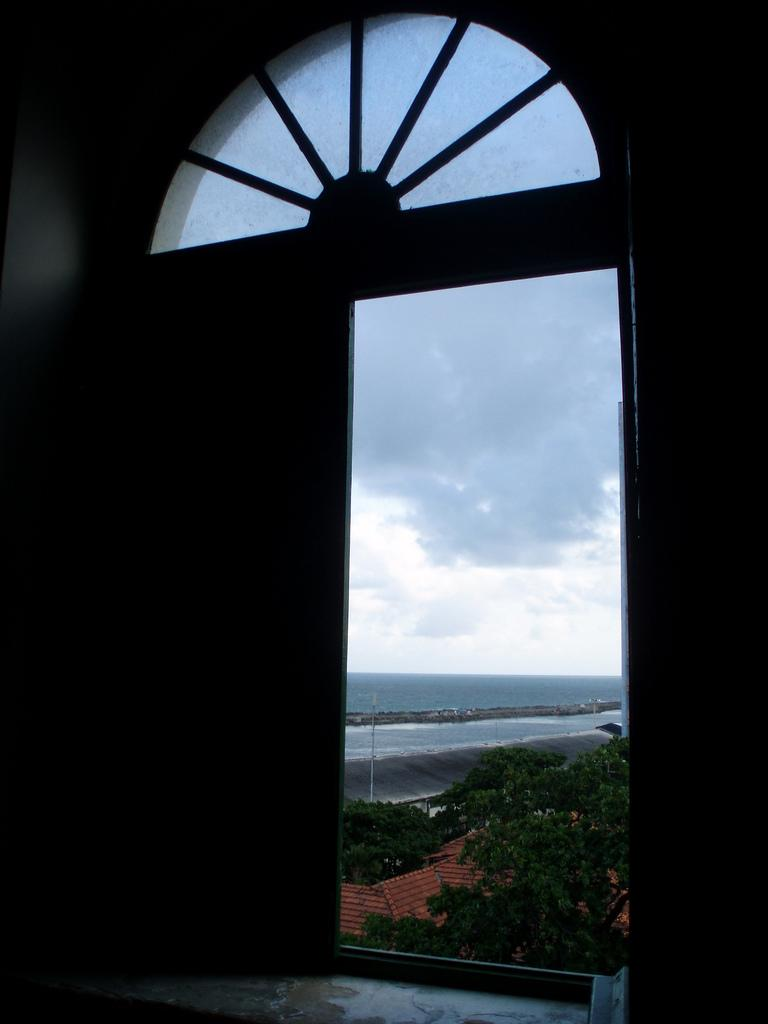What can be seen in the image that provides a view of the outdoors? There is a window in the image. What is visible in the background of the image through the window? There are trees in the background of the image. What else can be seen in the sky in the background of the image? There are clouds in the sky in the background of the image. What type of bait is being used to catch fish in the image? There is no mention of fish or bait in the image; it only features a window, trees, and clouds in the sky. 